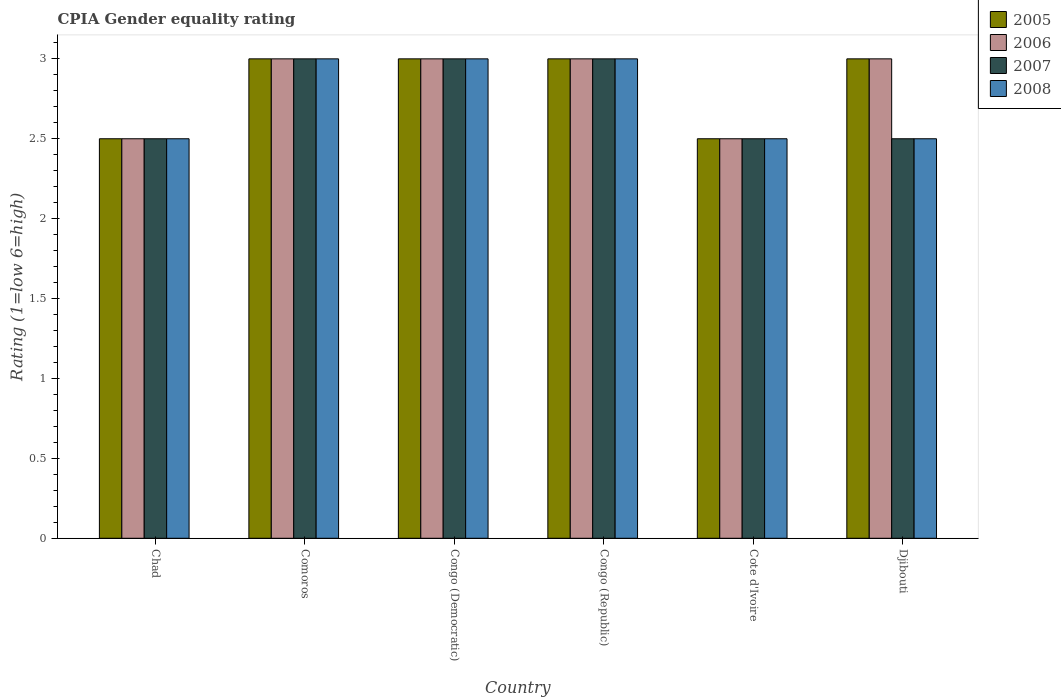How many different coloured bars are there?
Offer a very short reply. 4. Are the number of bars on each tick of the X-axis equal?
Provide a short and direct response. Yes. How many bars are there on the 6th tick from the right?
Provide a short and direct response. 4. What is the label of the 6th group of bars from the left?
Offer a very short reply. Djibouti. What is the CPIA rating in 2007 in Comoros?
Provide a short and direct response. 3. Across all countries, what is the minimum CPIA rating in 2006?
Your response must be concise. 2.5. In which country was the CPIA rating in 2007 maximum?
Make the answer very short. Comoros. In which country was the CPIA rating in 2007 minimum?
Ensure brevity in your answer.  Chad. What is the difference between the CPIA rating in 2008 in Comoros and that in Cote d'Ivoire?
Give a very brief answer. 0.5. What is the difference between the CPIA rating in 2006 in Chad and the CPIA rating in 2007 in Cote d'Ivoire?
Provide a succinct answer. 0. What is the average CPIA rating in 2005 per country?
Provide a short and direct response. 2.83. What is the difference between the CPIA rating of/in 2006 and CPIA rating of/in 2007 in Cote d'Ivoire?
Your answer should be compact. 0. In how many countries, is the CPIA rating in 2008 greater than 0.2?
Offer a very short reply. 6. What is the ratio of the CPIA rating in 2008 in Comoros to that in Congo (Republic)?
Ensure brevity in your answer.  1. Is the difference between the CPIA rating in 2006 in Comoros and Djibouti greater than the difference between the CPIA rating in 2007 in Comoros and Djibouti?
Make the answer very short. No. What is the difference between the highest and the lowest CPIA rating in 2007?
Offer a terse response. 0.5. Is the sum of the CPIA rating in 2007 in Chad and Congo (Democratic) greater than the maximum CPIA rating in 2008 across all countries?
Your answer should be compact. Yes. What does the 4th bar from the left in Comoros represents?
Make the answer very short. 2008. How many bars are there?
Provide a succinct answer. 24. How many countries are there in the graph?
Ensure brevity in your answer.  6. What is the title of the graph?
Provide a short and direct response. CPIA Gender equality rating. Does "1960" appear as one of the legend labels in the graph?
Make the answer very short. No. What is the label or title of the X-axis?
Provide a succinct answer. Country. What is the label or title of the Y-axis?
Offer a very short reply. Rating (1=low 6=high). What is the Rating (1=low 6=high) of 2006 in Chad?
Your response must be concise. 2.5. What is the Rating (1=low 6=high) in 2007 in Chad?
Offer a very short reply. 2.5. What is the Rating (1=low 6=high) of 2007 in Comoros?
Offer a terse response. 3. What is the Rating (1=low 6=high) of 2007 in Congo (Democratic)?
Your answer should be compact. 3. What is the Rating (1=low 6=high) of 2008 in Congo (Democratic)?
Your answer should be very brief. 3. What is the Rating (1=low 6=high) in 2006 in Cote d'Ivoire?
Provide a short and direct response. 2.5. What is the Rating (1=low 6=high) in 2005 in Djibouti?
Provide a short and direct response. 3. Across all countries, what is the maximum Rating (1=low 6=high) of 2006?
Offer a terse response. 3. Across all countries, what is the maximum Rating (1=low 6=high) of 2007?
Ensure brevity in your answer.  3. Across all countries, what is the maximum Rating (1=low 6=high) in 2008?
Provide a short and direct response. 3. Across all countries, what is the minimum Rating (1=low 6=high) in 2005?
Ensure brevity in your answer.  2.5. Across all countries, what is the minimum Rating (1=low 6=high) of 2006?
Offer a very short reply. 2.5. What is the total Rating (1=low 6=high) in 2005 in the graph?
Your answer should be very brief. 17. What is the total Rating (1=low 6=high) of 2006 in the graph?
Make the answer very short. 17. What is the difference between the Rating (1=low 6=high) of 2005 in Chad and that in Comoros?
Provide a short and direct response. -0.5. What is the difference between the Rating (1=low 6=high) of 2006 in Chad and that in Comoros?
Keep it short and to the point. -0.5. What is the difference between the Rating (1=low 6=high) of 2007 in Chad and that in Congo (Democratic)?
Ensure brevity in your answer.  -0.5. What is the difference between the Rating (1=low 6=high) in 2008 in Chad and that in Congo (Democratic)?
Your response must be concise. -0.5. What is the difference between the Rating (1=low 6=high) of 2008 in Chad and that in Congo (Republic)?
Give a very brief answer. -0.5. What is the difference between the Rating (1=low 6=high) of 2005 in Chad and that in Cote d'Ivoire?
Your answer should be very brief. 0. What is the difference between the Rating (1=low 6=high) of 2006 in Chad and that in Cote d'Ivoire?
Your response must be concise. 0. What is the difference between the Rating (1=low 6=high) in 2007 in Chad and that in Cote d'Ivoire?
Your answer should be compact. 0. What is the difference between the Rating (1=low 6=high) of 2008 in Chad and that in Cote d'Ivoire?
Provide a succinct answer. 0. What is the difference between the Rating (1=low 6=high) in 2008 in Chad and that in Djibouti?
Provide a succinct answer. 0. What is the difference between the Rating (1=low 6=high) in 2006 in Comoros and that in Congo (Democratic)?
Ensure brevity in your answer.  0. What is the difference between the Rating (1=low 6=high) in 2007 in Comoros and that in Congo (Democratic)?
Offer a terse response. 0. What is the difference between the Rating (1=low 6=high) in 2007 in Comoros and that in Cote d'Ivoire?
Provide a succinct answer. 0.5. What is the difference between the Rating (1=low 6=high) of 2008 in Comoros and that in Cote d'Ivoire?
Offer a very short reply. 0.5. What is the difference between the Rating (1=low 6=high) in 2007 in Comoros and that in Djibouti?
Offer a very short reply. 0.5. What is the difference between the Rating (1=low 6=high) of 2005 in Congo (Democratic) and that in Congo (Republic)?
Give a very brief answer. 0. What is the difference between the Rating (1=low 6=high) of 2006 in Congo (Democratic) and that in Cote d'Ivoire?
Offer a terse response. 0.5. What is the difference between the Rating (1=low 6=high) in 2007 in Congo (Democratic) and that in Cote d'Ivoire?
Your response must be concise. 0.5. What is the difference between the Rating (1=low 6=high) in 2008 in Congo (Democratic) and that in Cote d'Ivoire?
Keep it short and to the point. 0.5. What is the difference between the Rating (1=low 6=high) of 2006 in Congo (Democratic) and that in Djibouti?
Your response must be concise. 0. What is the difference between the Rating (1=low 6=high) of 2007 in Congo (Democratic) and that in Djibouti?
Ensure brevity in your answer.  0.5. What is the difference between the Rating (1=low 6=high) in 2008 in Congo (Democratic) and that in Djibouti?
Your answer should be compact. 0.5. What is the difference between the Rating (1=low 6=high) in 2005 in Congo (Republic) and that in Cote d'Ivoire?
Provide a succinct answer. 0.5. What is the difference between the Rating (1=low 6=high) of 2007 in Congo (Republic) and that in Cote d'Ivoire?
Your answer should be compact. 0.5. What is the difference between the Rating (1=low 6=high) of 2007 in Congo (Republic) and that in Djibouti?
Give a very brief answer. 0.5. What is the difference between the Rating (1=low 6=high) in 2005 in Cote d'Ivoire and that in Djibouti?
Make the answer very short. -0.5. What is the difference between the Rating (1=low 6=high) of 2006 in Cote d'Ivoire and that in Djibouti?
Ensure brevity in your answer.  -0.5. What is the difference between the Rating (1=low 6=high) of 2006 in Chad and the Rating (1=low 6=high) of 2007 in Comoros?
Ensure brevity in your answer.  -0.5. What is the difference between the Rating (1=low 6=high) of 2006 in Chad and the Rating (1=low 6=high) of 2008 in Comoros?
Make the answer very short. -0.5. What is the difference between the Rating (1=low 6=high) in 2005 in Chad and the Rating (1=low 6=high) in 2006 in Congo (Democratic)?
Provide a short and direct response. -0.5. What is the difference between the Rating (1=low 6=high) in 2006 in Chad and the Rating (1=low 6=high) in 2007 in Congo (Democratic)?
Offer a terse response. -0.5. What is the difference between the Rating (1=low 6=high) in 2007 in Chad and the Rating (1=low 6=high) in 2008 in Congo (Democratic)?
Your answer should be compact. -0.5. What is the difference between the Rating (1=low 6=high) in 2005 in Chad and the Rating (1=low 6=high) in 2007 in Congo (Republic)?
Your answer should be very brief. -0.5. What is the difference between the Rating (1=low 6=high) of 2006 in Chad and the Rating (1=low 6=high) of 2008 in Congo (Republic)?
Provide a succinct answer. -0.5. What is the difference between the Rating (1=low 6=high) in 2007 in Chad and the Rating (1=low 6=high) in 2008 in Congo (Republic)?
Offer a terse response. -0.5. What is the difference between the Rating (1=low 6=high) in 2005 in Chad and the Rating (1=low 6=high) in 2007 in Cote d'Ivoire?
Keep it short and to the point. 0. What is the difference between the Rating (1=low 6=high) of 2005 in Chad and the Rating (1=low 6=high) of 2008 in Cote d'Ivoire?
Offer a terse response. 0. What is the difference between the Rating (1=low 6=high) in 2006 in Chad and the Rating (1=low 6=high) in 2007 in Cote d'Ivoire?
Provide a succinct answer. 0. What is the difference between the Rating (1=low 6=high) in 2005 in Chad and the Rating (1=low 6=high) in 2006 in Djibouti?
Make the answer very short. -0.5. What is the difference between the Rating (1=low 6=high) in 2005 in Chad and the Rating (1=low 6=high) in 2007 in Djibouti?
Offer a very short reply. 0. What is the difference between the Rating (1=low 6=high) of 2006 in Chad and the Rating (1=low 6=high) of 2008 in Djibouti?
Give a very brief answer. 0. What is the difference between the Rating (1=low 6=high) of 2005 in Comoros and the Rating (1=low 6=high) of 2006 in Congo (Democratic)?
Your answer should be compact. 0. What is the difference between the Rating (1=low 6=high) of 2006 in Comoros and the Rating (1=low 6=high) of 2007 in Congo (Democratic)?
Provide a succinct answer. 0. What is the difference between the Rating (1=low 6=high) of 2007 in Comoros and the Rating (1=low 6=high) of 2008 in Congo (Democratic)?
Provide a short and direct response. 0. What is the difference between the Rating (1=low 6=high) in 2005 in Comoros and the Rating (1=low 6=high) in 2006 in Congo (Republic)?
Make the answer very short. 0. What is the difference between the Rating (1=low 6=high) in 2005 in Comoros and the Rating (1=low 6=high) in 2007 in Congo (Republic)?
Provide a succinct answer. 0. What is the difference between the Rating (1=low 6=high) of 2006 in Comoros and the Rating (1=low 6=high) of 2007 in Congo (Republic)?
Offer a terse response. 0. What is the difference between the Rating (1=low 6=high) in 2007 in Comoros and the Rating (1=low 6=high) in 2008 in Congo (Republic)?
Offer a terse response. 0. What is the difference between the Rating (1=low 6=high) in 2005 in Comoros and the Rating (1=low 6=high) in 2006 in Cote d'Ivoire?
Ensure brevity in your answer.  0.5. What is the difference between the Rating (1=low 6=high) in 2005 in Comoros and the Rating (1=low 6=high) in 2007 in Cote d'Ivoire?
Offer a terse response. 0.5. What is the difference between the Rating (1=low 6=high) in 2005 in Comoros and the Rating (1=low 6=high) in 2008 in Cote d'Ivoire?
Your answer should be very brief. 0.5. What is the difference between the Rating (1=low 6=high) of 2005 in Comoros and the Rating (1=low 6=high) of 2007 in Djibouti?
Make the answer very short. 0.5. What is the difference between the Rating (1=low 6=high) of 2005 in Comoros and the Rating (1=low 6=high) of 2008 in Djibouti?
Offer a terse response. 0.5. What is the difference between the Rating (1=low 6=high) of 2007 in Comoros and the Rating (1=low 6=high) of 2008 in Djibouti?
Provide a short and direct response. 0.5. What is the difference between the Rating (1=low 6=high) of 2005 in Congo (Democratic) and the Rating (1=low 6=high) of 2007 in Congo (Republic)?
Give a very brief answer. 0. What is the difference between the Rating (1=low 6=high) in 2005 in Congo (Democratic) and the Rating (1=low 6=high) in 2008 in Congo (Republic)?
Offer a very short reply. 0. What is the difference between the Rating (1=low 6=high) of 2006 in Congo (Democratic) and the Rating (1=low 6=high) of 2007 in Congo (Republic)?
Your response must be concise. 0. What is the difference between the Rating (1=low 6=high) of 2006 in Congo (Democratic) and the Rating (1=low 6=high) of 2008 in Congo (Republic)?
Give a very brief answer. 0. What is the difference between the Rating (1=low 6=high) in 2007 in Congo (Democratic) and the Rating (1=low 6=high) in 2008 in Congo (Republic)?
Give a very brief answer. 0. What is the difference between the Rating (1=low 6=high) in 2005 in Congo (Democratic) and the Rating (1=low 6=high) in 2006 in Cote d'Ivoire?
Your answer should be compact. 0.5. What is the difference between the Rating (1=low 6=high) of 2005 in Congo (Democratic) and the Rating (1=low 6=high) of 2007 in Cote d'Ivoire?
Keep it short and to the point. 0.5. What is the difference between the Rating (1=low 6=high) of 2006 in Congo (Democratic) and the Rating (1=low 6=high) of 2007 in Cote d'Ivoire?
Provide a succinct answer. 0.5. What is the difference between the Rating (1=low 6=high) in 2006 in Congo (Democratic) and the Rating (1=low 6=high) in 2008 in Cote d'Ivoire?
Your response must be concise. 0.5. What is the difference between the Rating (1=low 6=high) of 2005 in Congo (Democratic) and the Rating (1=low 6=high) of 2006 in Djibouti?
Your answer should be very brief. 0. What is the difference between the Rating (1=low 6=high) in 2005 in Congo (Democratic) and the Rating (1=low 6=high) in 2007 in Djibouti?
Make the answer very short. 0.5. What is the difference between the Rating (1=low 6=high) in 2007 in Congo (Democratic) and the Rating (1=low 6=high) in 2008 in Djibouti?
Keep it short and to the point. 0.5. What is the difference between the Rating (1=low 6=high) in 2006 in Congo (Republic) and the Rating (1=low 6=high) in 2008 in Cote d'Ivoire?
Make the answer very short. 0.5. What is the difference between the Rating (1=low 6=high) of 2005 in Congo (Republic) and the Rating (1=low 6=high) of 2008 in Djibouti?
Keep it short and to the point. 0.5. What is the difference between the Rating (1=low 6=high) in 2006 in Congo (Republic) and the Rating (1=low 6=high) in 2008 in Djibouti?
Make the answer very short. 0.5. What is the difference between the Rating (1=low 6=high) of 2006 in Cote d'Ivoire and the Rating (1=low 6=high) of 2007 in Djibouti?
Your answer should be very brief. 0. What is the difference between the Rating (1=low 6=high) of 2006 in Cote d'Ivoire and the Rating (1=low 6=high) of 2008 in Djibouti?
Your response must be concise. 0. What is the average Rating (1=low 6=high) of 2005 per country?
Provide a succinct answer. 2.83. What is the average Rating (1=low 6=high) in 2006 per country?
Your answer should be compact. 2.83. What is the average Rating (1=low 6=high) in 2007 per country?
Offer a terse response. 2.75. What is the average Rating (1=low 6=high) of 2008 per country?
Your response must be concise. 2.75. What is the difference between the Rating (1=low 6=high) of 2005 and Rating (1=low 6=high) of 2008 in Chad?
Your answer should be very brief. 0. What is the difference between the Rating (1=low 6=high) of 2006 and Rating (1=low 6=high) of 2007 in Chad?
Ensure brevity in your answer.  0. What is the difference between the Rating (1=low 6=high) of 2007 and Rating (1=low 6=high) of 2008 in Chad?
Offer a terse response. 0. What is the difference between the Rating (1=low 6=high) of 2005 and Rating (1=low 6=high) of 2006 in Comoros?
Provide a short and direct response. 0. What is the difference between the Rating (1=low 6=high) in 2005 and Rating (1=low 6=high) in 2007 in Comoros?
Your answer should be very brief. 0. What is the difference between the Rating (1=low 6=high) in 2005 and Rating (1=low 6=high) in 2008 in Comoros?
Your response must be concise. 0. What is the difference between the Rating (1=low 6=high) of 2006 and Rating (1=low 6=high) of 2007 in Comoros?
Keep it short and to the point. 0. What is the difference between the Rating (1=low 6=high) in 2006 and Rating (1=low 6=high) in 2008 in Comoros?
Your answer should be very brief. 0. What is the difference between the Rating (1=low 6=high) in 2005 and Rating (1=low 6=high) in 2006 in Congo (Democratic)?
Offer a terse response. 0. What is the difference between the Rating (1=low 6=high) in 2005 and Rating (1=low 6=high) in 2007 in Congo (Democratic)?
Offer a very short reply. 0. What is the difference between the Rating (1=low 6=high) of 2006 and Rating (1=low 6=high) of 2007 in Congo (Democratic)?
Make the answer very short. 0. What is the difference between the Rating (1=low 6=high) of 2007 and Rating (1=low 6=high) of 2008 in Congo (Democratic)?
Make the answer very short. 0. What is the difference between the Rating (1=low 6=high) of 2005 and Rating (1=low 6=high) of 2007 in Congo (Republic)?
Your response must be concise. 0. What is the difference between the Rating (1=low 6=high) of 2006 and Rating (1=low 6=high) of 2007 in Congo (Republic)?
Provide a succinct answer. 0. What is the difference between the Rating (1=low 6=high) of 2006 and Rating (1=low 6=high) of 2008 in Congo (Republic)?
Your answer should be compact. 0. What is the difference between the Rating (1=low 6=high) in 2005 and Rating (1=low 6=high) in 2008 in Cote d'Ivoire?
Provide a succinct answer. 0. What is the difference between the Rating (1=low 6=high) of 2006 and Rating (1=low 6=high) of 2008 in Cote d'Ivoire?
Give a very brief answer. 0. What is the difference between the Rating (1=low 6=high) in 2007 and Rating (1=low 6=high) in 2008 in Cote d'Ivoire?
Make the answer very short. 0. What is the difference between the Rating (1=low 6=high) in 2005 and Rating (1=low 6=high) in 2006 in Djibouti?
Make the answer very short. 0. What is the difference between the Rating (1=low 6=high) in 2005 and Rating (1=low 6=high) in 2007 in Djibouti?
Your answer should be very brief. 0.5. What is the difference between the Rating (1=low 6=high) in 2006 and Rating (1=low 6=high) in 2007 in Djibouti?
Keep it short and to the point. 0.5. What is the difference between the Rating (1=low 6=high) of 2006 and Rating (1=low 6=high) of 2008 in Djibouti?
Give a very brief answer. 0.5. What is the ratio of the Rating (1=low 6=high) in 2005 in Chad to that in Comoros?
Offer a very short reply. 0.83. What is the ratio of the Rating (1=low 6=high) in 2006 in Chad to that in Comoros?
Your answer should be very brief. 0.83. What is the ratio of the Rating (1=low 6=high) of 2007 in Chad to that in Comoros?
Your response must be concise. 0.83. What is the ratio of the Rating (1=low 6=high) in 2006 in Chad to that in Congo (Democratic)?
Keep it short and to the point. 0.83. What is the ratio of the Rating (1=low 6=high) in 2008 in Chad to that in Congo (Democratic)?
Offer a very short reply. 0.83. What is the ratio of the Rating (1=low 6=high) of 2005 in Chad to that in Congo (Republic)?
Your answer should be compact. 0.83. What is the ratio of the Rating (1=low 6=high) of 2007 in Chad to that in Congo (Republic)?
Keep it short and to the point. 0.83. What is the ratio of the Rating (1=low 6=high) of 2006 in Chad to that in Cote d'Ivoire?
Offer a terse response. 1. What is the ratio of the Rating (1=low 6=high) in 2008 in Chad to that in Cote d'Ivoire?
Offer a terse response. 1. What is the ratio of the Rating (1=low 6=high) of 2006 in Chad to that in Djibouti?
Your response must be concise. 0.83. What is the ratio of the Rating (1=low 6=high) of 2007 in Chad to that in Djibouti?
Ensure brevity in your answer.  1. What is the ratio of the Rating (1=low 6=high) of 2008 in Chad to that in Djibouti?
Your response must be concise. 1. What is the ratio of the Rating (1=low 6=high) in 2005 in Comoros to that in Congo (Democratic)?
Your answer should be very brief. 1. What is the ratio of the Rating (1=low 6=high) of 2007 in Comoros to that in Congo (Democratic)?
Your answer should be compact. 1. What is the ratio of the Rating (1=low 6=high) in 2008 in Comoros to that in Congo (Democratic)?
Offer a terse response. 1. What is the ratio of the Rating (1=low 6=high) of 2008 in Comoros to that in Congo (Republic)?
Make the answer very short. 1. What is the ratio of the Rating (1=low 6=high) of 2005 in Comoros to that in Djibouti?
Give a very brief answer. 1. What is the ratio of the Rating (1=low 6=high) in 2006 in Congo (Democratic) to that in Congo (Republic)?
Offer a terse response. 1. What is the ratio of the Rating (1=low 6=high) in 2007 in Congo (Democratic) to that in Congo (Republic)?
Your answer should be compact. 1. What is the ratio of the Rating (1=low 6=high) of 2006 in Congo (Democratic) to that in Cote d'Ivoire?
Give a very brief answer. 1.2. What is the ratio of the Rating (1=low 6=high) in 2007 in Congo (Democratic) to that in Cote d'Ivoire?
Give a very brief answer. 1.2. What is the ratio of the Rating (1=low 6=high) in 2005 in Congo (Democratic) to that in Djibouti?
Your response must be concise. 1. What is the ratio of the Rating (1=low 6=high) in 2006 in Congo (Democratic) to that in Djibouti?
Provide a short and direct response. 1. What is the ratio of the Rating (1=low 6=high) of 2007 in Congo (Democratic) to that in Djibouti?
Your answer should be compact. 1.2. What is the ratio of the Rating (1=low 6=high) in 2005 in Congo (Republic) to that in Cote d'Ivoire?
Ensure brevity in your answer.  1.2. What is the ratio of the Rating (1=low 6=high) of 2007 in Congo (Republic) to that in Cote d'Ivoire?
Give a very brief answer. 1.2. What is the ratio of the Rating (1=low 6=high) of 2005 in Congo (Republic) to that in Djibouti?
Offer a terse response. 1. What is the ratio of the Rating (1=low 6=high) of 2007 in Congo (Republic) to that in Djibouti?
Provide a succinct answer. 1.2. What is the ratio of the Rating (1=low 6=high) of 2005 in Cote d'Ivoire to that in Djibouti?
Your response must be concise. 0.83. What is the ratio of the Rating (1=low 6=high) in 2008 in Cote d'Ivoire to that in Djibouti?
Your response must be concise. 1. What is the difference between the highest and the second highest Rating (1=low 6=high) of 2006?
Offer a terse response. 0. What is the difference between the highest and the second highest Rating (1=low 6=high) in 2007?
Offer a terse response. 0. What is the difference between the highest and the lowest Rating (1=low 6=high) of 2005?
Your response must be concise. 0.5. What is the difference between the highest and the lowest Rating (1=low 6=high) of 2007?
Your answer should be compact. 0.5. 